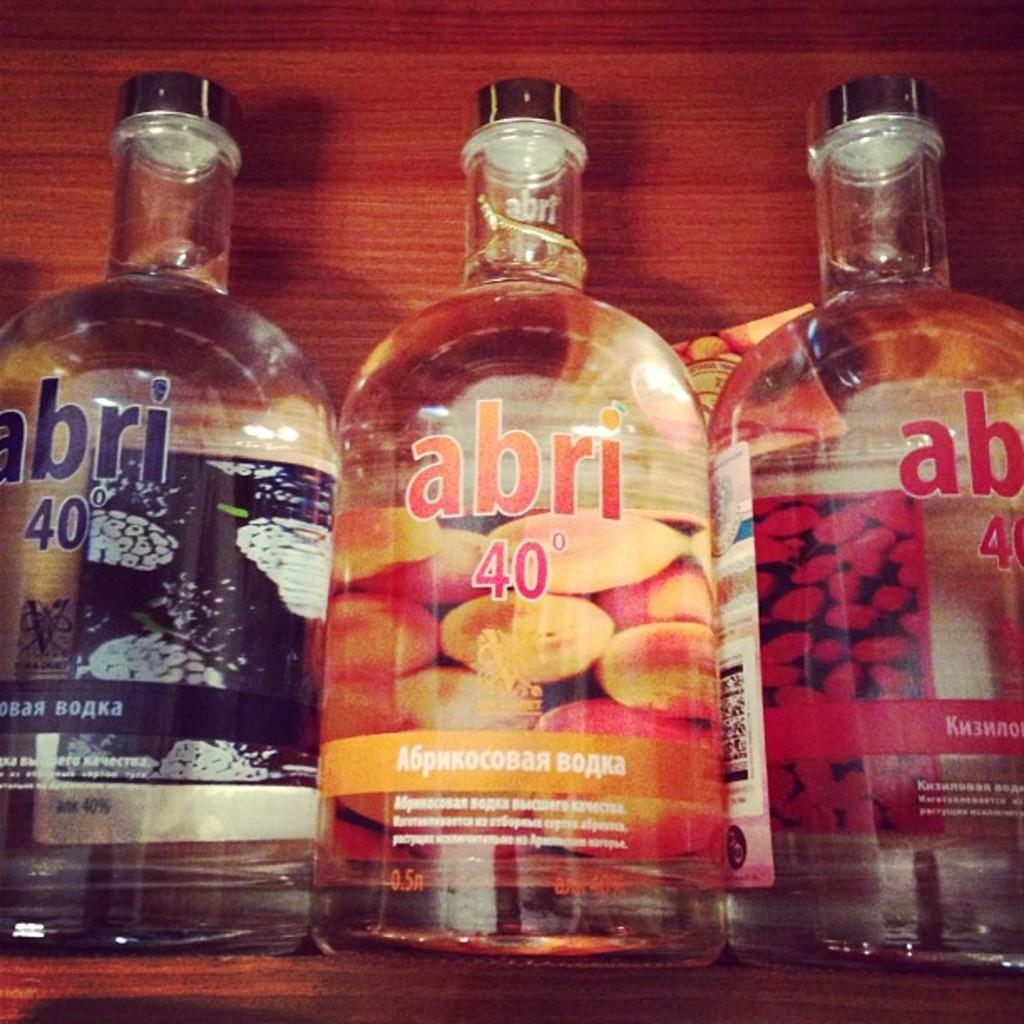<image>
Write a terse but informative summary of the picture. three different colored bottles of clear liquor by abri 